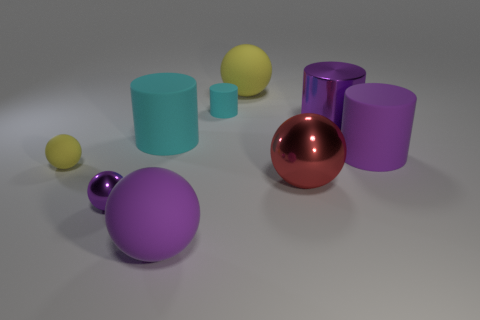There is a metal sphere that is the same color as the metallic cylinder; what is its size?
Ensure brevity in your answer.  Small. What number of other big metallic cylinders have the same color as the big metallic cylinder?
Your answer should be compact. 0. There is a tiny sphere that is the same color as the big metal cylinder; what is it made of?
Give a very brief answer. Metal. Is the number of small purple objects to the right of the tiny metallic object greater than the number of red shiny balls?
Make the answer very short. No. Is the shape of the small yellow rubber object the same as the red thing?
Your answer should be compact. Yes. How many large yellow things are made of the same material as the big red ball?
Your answer should be compact. 0. What size is the other yellow rubber object that is the same shape as the big yellow rubber thing?
Your answer should be compact. Small. Is the size of the red sphere the same as the purple matte ball?
Provide a succinct answer. Yes. What shape is the matte thing in front of the yellow object that is in front of the yellow matte object behind the tiny cylinder?
Your response must be concise. Sphere. There is another small metal thing that is the same shape as the red metal thing; what is its color?
Offer a very short reply. Purple. 